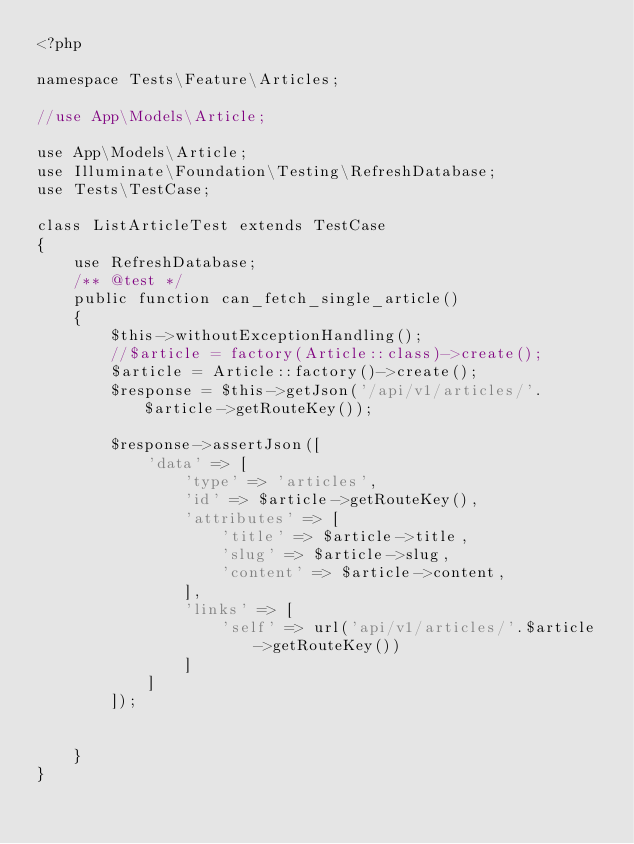Convert code to text. <code><loc_0><loc_0><loc_500><loc_500><_PHP_><?php

namespace Tests\Feature\Articles;

//use App\Models\Article;

use App\Models\Article;
use Illuminate\Foundation\Testing\RefreshDatabase;
use Tests\TestCase;

class ListArticleTest extends TestCase
{
    use RefreshDatabase;
    /** @test */
    public function can_fetch_single_article()
    {
        $this->withoutExceptionHandling();
        //$article = factory(Article::class)->create();
        $article = Article::factory()->create();
        $response = $this->getJson('/api/v1/articles/'.$article->getRouteKey());

        $response->assertJson([
            'data' => [
                'type' => 'articles',
                'id' => $article->getRouteKey(),
                'attributes' => [
                    'title' => $article->title,
                    'slug' => $article->slug,
                    'content' => $article->content,
                ],
                'links' => [
                    'self' => url('api/v1/articles/'.$article->getRouteKey())
                ]
            ]
        ]);


    }
}
</code> 